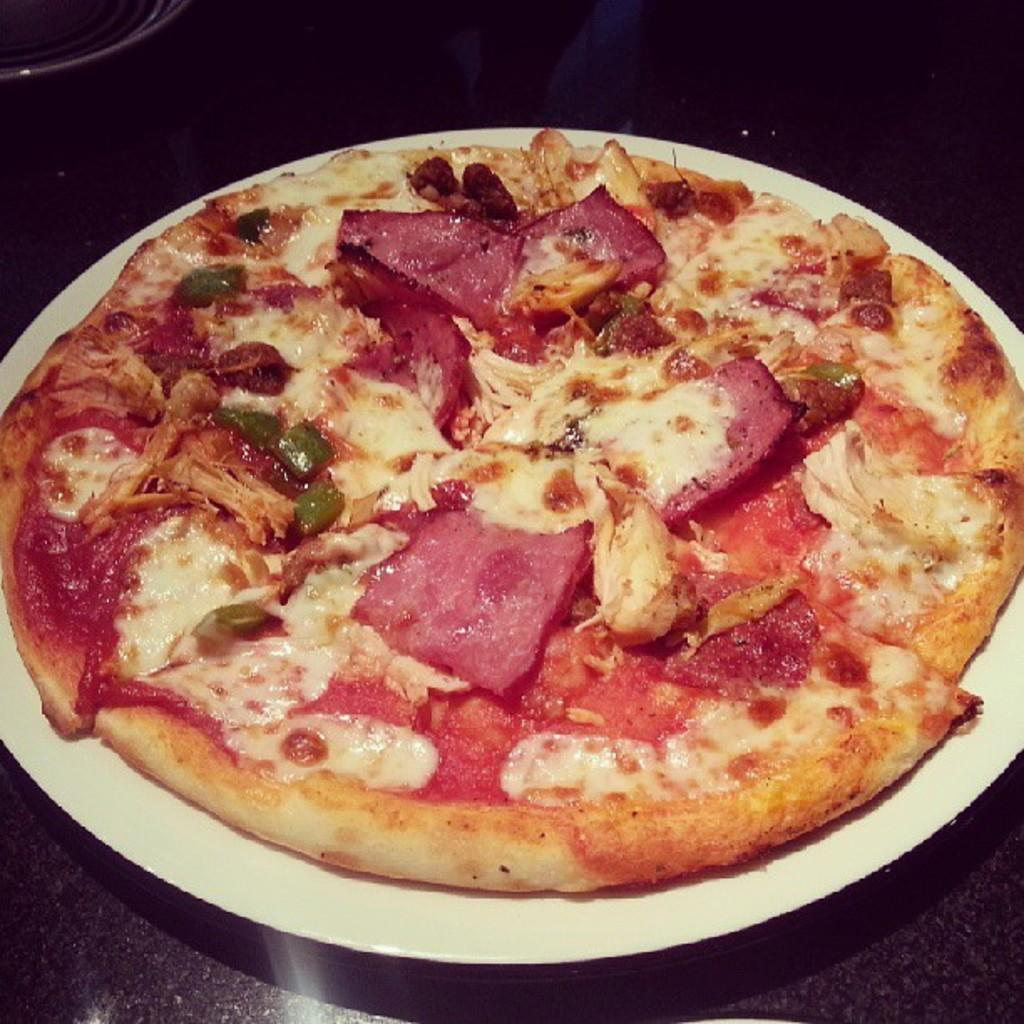What type of food is visible in the image? There is a pizza in the image. How is the pizza presented? The pizza is in a plate. Where is the plate with the pizza located? The plate with the pizza is placed on a table. Are there any other plates visible in the image? Yes, there is another plate in the image. What type of cork can be seen in the image? There is no cork present in the image. How many fingers are visible in the image? There is no indication of fingers in the image; it only shows a pizza in a plate and another plate. 